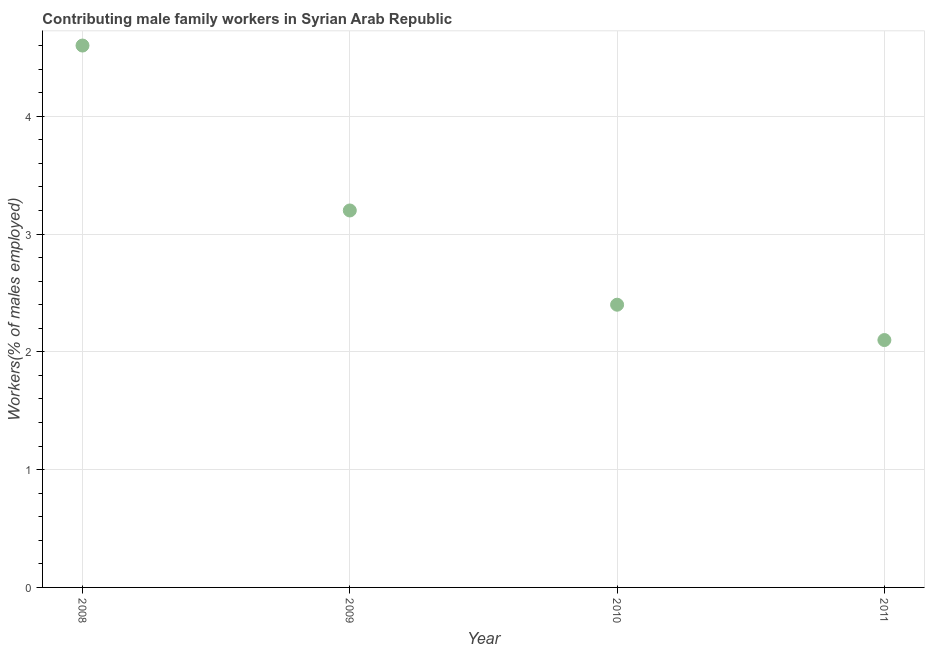What is the contributing male family workers in 2008?
Offer a very short reply. 4.6. Across all years, what is the maximum contributing male family workers?
Keep it short and to the point. 4.6. Across all years, what is the minimum contributing male family workers?
Offer a terse response. 2.1. In which year was the contributing male family workers maximum?
Provide a short and direct response. 2008. What is the sum of the contributing male family workers?
Your answer should be compact. 12.3. What is the difference between the contributing male family workers in 2010 and 2011?
Provide a succinct answer. 0.3. What is the average contributing male family workers per year?
Your response must be concise. 3.07. What is the median contributing male family workers?
Provide a succinct answer. 2.8. What is the ratio of the contributing male family workers in 2009 to that in 2010?
Give a very brief answer. 1.33. Is the contributing male family workers in 2009 less than that in 2011?
Your response must be concise. No. What is the difference between the highest and the second highest contributing male family workers?
Ensure brevity in your answer.  1.4. Is the sum of the contributing male family workers in 2008 and 2011 greater than the maximum contributing male family workers across all years?
Offer a terse response. Yes. How many years are there in the graph?
Give a very brief answer. 4. Are the values on the major ticks of Y-axis written in scientific E-notation?
Your response must be concise. No. Does the graph contain grids?
Ensure brevity in your answer.  Yes. What is the title of the graph?
Give a very brief answer. Contributing male family workers in Syrian Arab Republic. What is the label or title of the Y-axis?
Offer a terse response. Workers(% of males employed). What is the Workers(% of males employed) in 2008?
Offer a very short reply. 4.6. What is the Workers(% of males employed) in 2009?
Your answer should be compact. 3.2. What is the Workers(% of males employed) in 2010?
Make the answer very short. 2.4. What is the Workers(% of males employed) in 2011?
Offer a very short reply. 2.1. What is the difference between the Workers(% of males employed) in 2008 and 2010?
Your answer should be compact. 2.2. What is the difference between the Workers(% of males employed) in 2008 and 2011?
Your answer should be compact. 2.5. What is the difference between the Workers(% of males employed) in 2009 and 2010?
Offer a very short reply. 0.8. What is the difference between the Workers(% of males employed) in 2009 and 2011?
Give a very brief answer. 1.1. What is the difference between the Workers(% of males employed) in 2010 and 2011?
Provide a short and direct response. 0.3. What is the ratio of the Workers(% of males employed) in 2008 to that in 2009?
Your response must be concise. 1.44. What is the ratio of the Workers(% of males employed) in 2008 to that in 2010?
Ensure brevity in your answer.  1.92. What is the ratio of the Workers(% of males employed) in 2008 to that in 2011?
Offer a very short reply. 2.19. What is the ratio of the Workers(% of males employed) in 2009 to that in 2010?
Your answer should be compact. 1.33. What is the ratio of the Workers(% of males employed) in 2009 to that in 2011?
Your response must be concise. 1.52. What is the ratio of the Workers(% of males employed) in 2010 to that in 2011?
Your response must be concise. 1.14. 